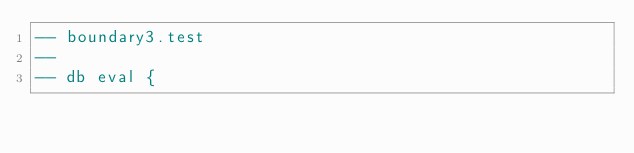Convert code to text. <code><loc_0><loc_0><loc_500><loc_500><_SQL_>-- boundary3.test
-- 
-- db eval {</code> 